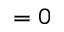Convert formula to latex. <formula><loc_0><loc_0><loc_500><loc_500>= 0</formula> 